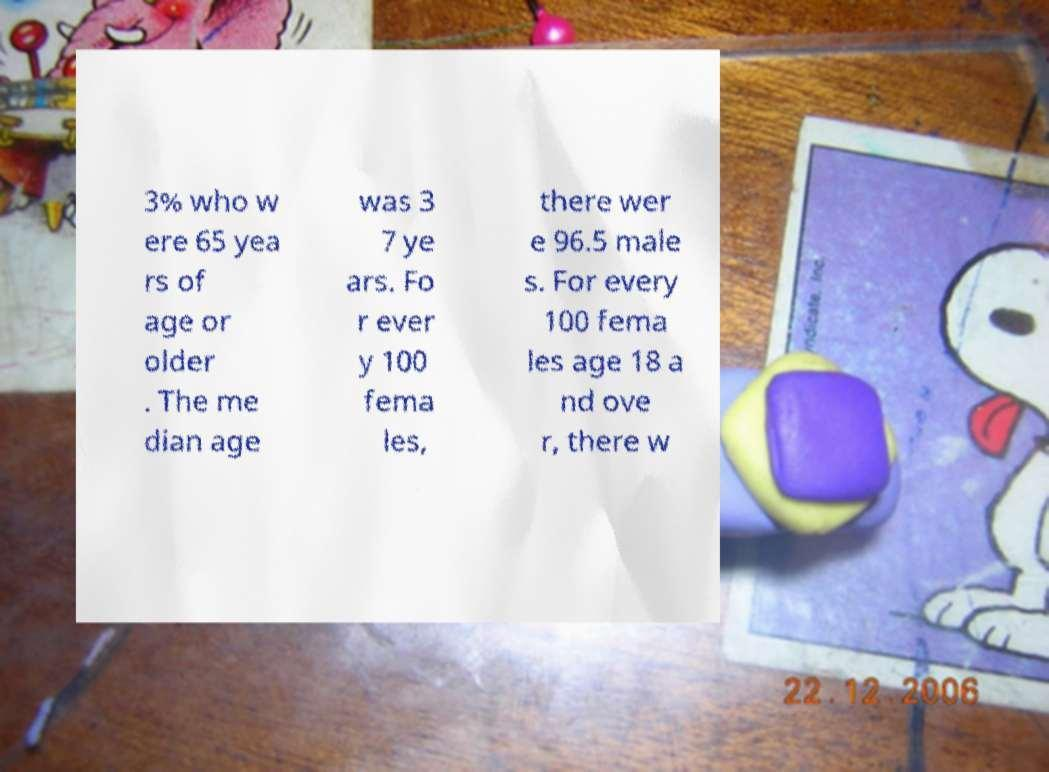Please read and relay the text visible in this image. What does it say? 3% who w ere 65 yea rs of age or older . The me dian age was 3 7 ye ars. Fo r ever y 100 fema les, there wer e 96.5 male s. For every 100 fema les age 18 a nd ove r, there w 